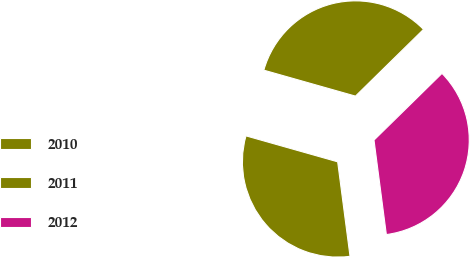Convert chart. <chart><loc_0><loc_0><loc_500><loc_500><pie_chart><fcel>2010<fcel>2011<fcel>2012<nl><fcel>33.26%<fcel>31.46%<fcel>35.28%<nl></chart> 